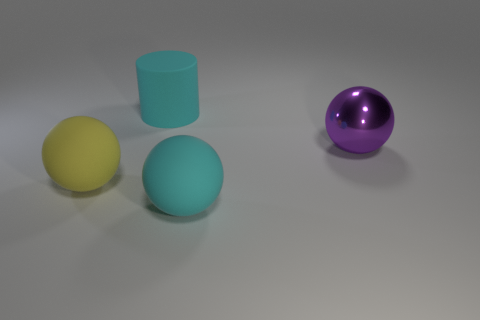Subtract all big yellow matte balls. How many balls are left? 2 Add 1 large purple spheres. How many objects exist? 5 Subtract 2 spheres. How many spheres are left? 1 Subtract all cylinders. How many objects are left? 3 Subtract 0 red cylinders. How many objects are left? 4 Subtract all yellow spheres. Subtract all red cubes. How many spheres are left? 2 Subtract all large green rubber cubes. Subtract all large objects. How many objects are left? 0 Add 2 large cyan matte balls. How many large cyan matte balls are left? 3 Add 2 yellow rubber blocks. How many yellow rubber blocks exist? 2 